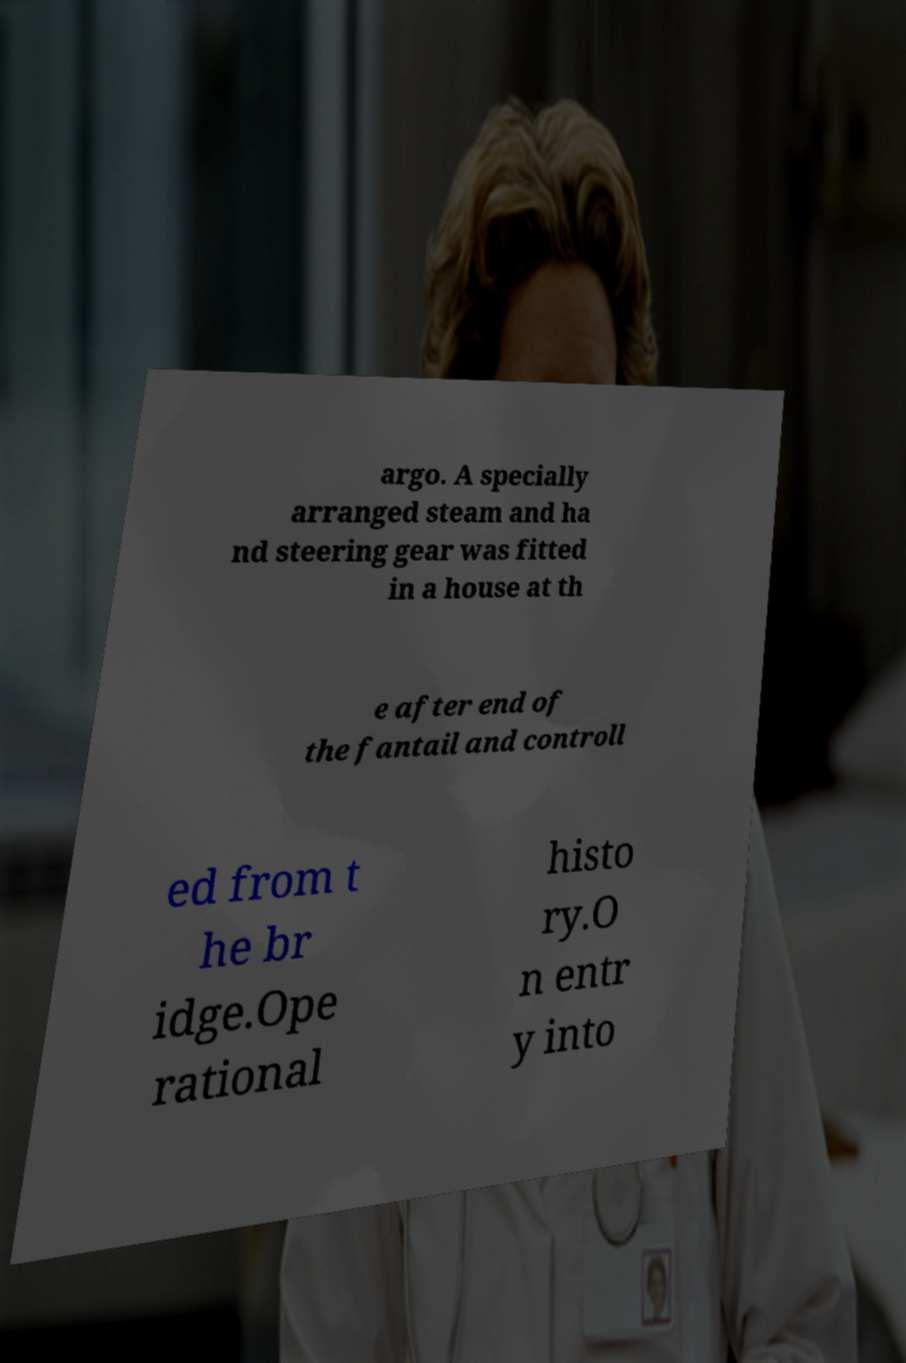I need the written content from this picture converted into text. Can you do that? argo. A specially arranged steam and ha nd steering gear was fitted in a house at th e after end of the fantail and controll ed from t he br idge.Ope rational histo ry.O n entr y into 